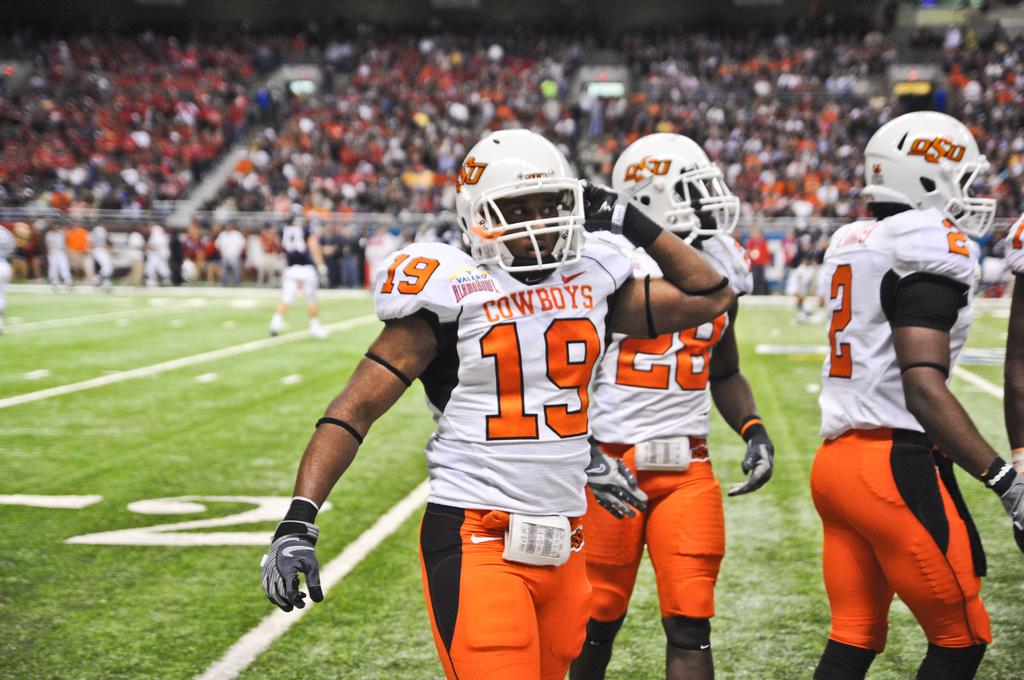How many people are in the image? There are four persons in the image. What are the four persons doing in the image? The four persons are playing a game. What is the ground surface like in the image? There is green grass at the bottom of the image. Where does the image appear to be set? The setting appears to be a stadium. What can be seen in the background of the image? There is a large crowd visible in the background of the image. What type of cheese is being used as a prop in the game? There is no cheese present in the image, and no cheese is being used as a prop in the game. 